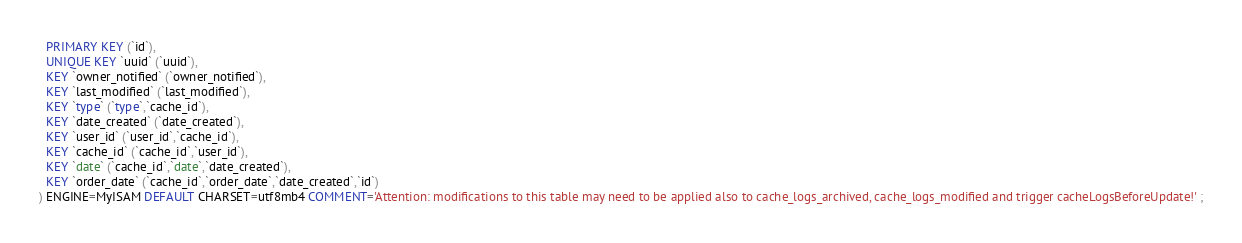Convert code to text. <code><loc_0><loc_0><loc_500><loc_500><_SQL_>  PRIMARY KEY (`id`),
  UNIQUE KEY `uuid` (`uuid`),
  KEY `owner_notified` (`owner_notified`),
  KEY `last_modified` (`last_modified`),
  KEY `type` (`type`,`cache_id`),
  KEY `date_created` (`date_created`),
  KEY `user_id` (`user_id`,`cache_id`),
  KEY `cache_id` (`cache_id`,`user_id`),
  KEY `date` (`cache_id`,`date`,`date_created`),
  KEY `order_date` (`cache_id`,`order_date`,`date_created`,`id`)
) ENGINE=MyISAM DEFAULT CHARSET=utf8mb4 COMMENT='Attention: modifications to this table may need to be applied also to cache_logs_archived, cache_logs_modified and trigger cacheLogsBeforeUpdate!' ;
</code> 